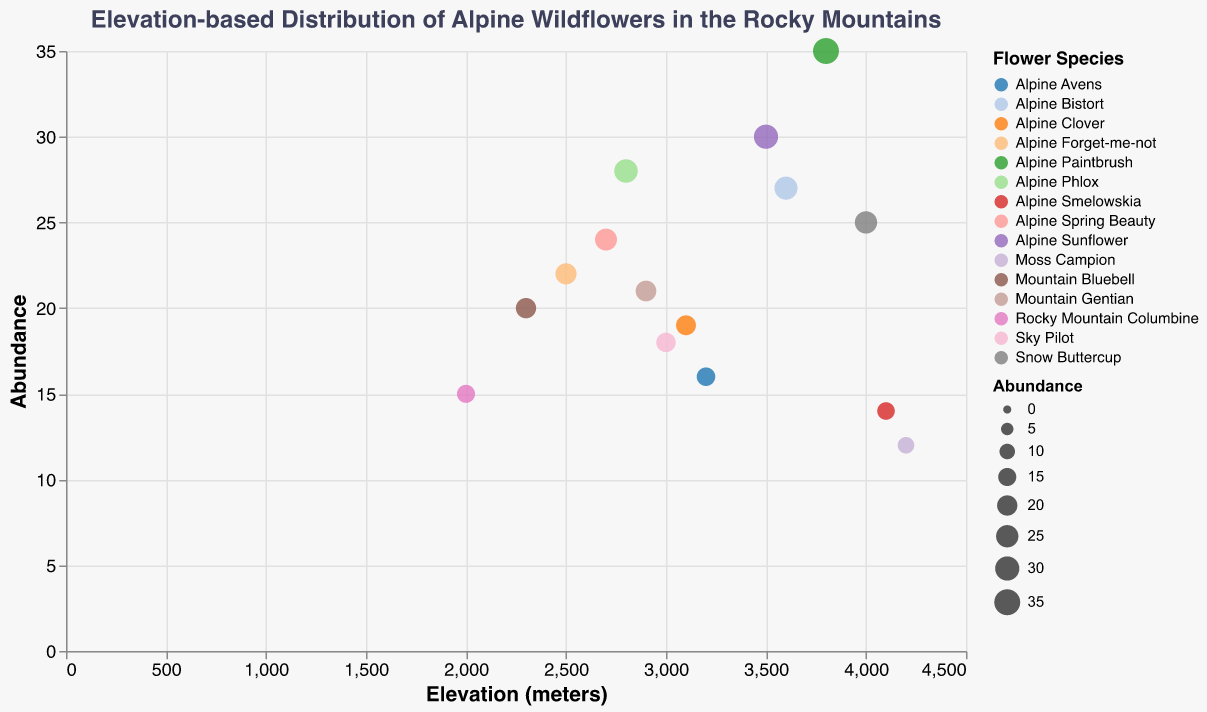What is the flower species with the highest abundance? Look at the y-axis representing abundance and identify the point with the highest value; the flower species corresponding to it is "Alpine Paintbrush".
Answer: Alpine Paintbrush Which flower species occurs at the highest elevation? Examine the x-axis representing elevation and find the point at the highest elevation. The flower species corresponding to it is "Moss Campion".
Answer: Moss Campion What is the average abundance of flowers found at or above 3000 meters? Identify the abundances of flowers at 3000 meters or above: Sky Pilot (18), Alpine Sunflower (30), Snow Buttercup (25), Alpine Avens (16), Alpine Paintbrush (35), Moss Campion (12), Alpine Clover (19), Alpine Bistort (27), Alpine Smelowskia (14). Sum these values: 18 + 30 + 25 + 16 + 35 + 12 + 19 + 27 + 14 = 196. There are 9 flowers, so average = 196 / 9.
Answer: 21.78 What is the difference in abundance between Rocky Mountain Columbine and Alpine Sunflower? Compare the y-axis values for both species: Rocky Mountain Columbine (15) and Alpine Sunflower (30). Calculate the difference: 30 - 15.
Answer: 15 Which flower species has the lowest abundance at an elevation between 3000 and 4000 meters? Focus on points between 3000 and 4000 meters on the x-axis. Compare their abundances: Sky Pilot (18), Alpine Avens (16), Alpine Clover (19), Alpine Bistort (27), Alpine Paintbrush (35), and Alpine Sunflower (30). The lowest value is for "Alpine Avens".
Answer: Alpine Avens Are there more flower species found above or below 3000 meters? Count the flower species above 3000 meters: Sky Pilot, Alpine Sunflower, Snow Buttercup, Alpine Avens, Alpine Paintbrush, Alpine Clover, Alpine Bistort, Alpine Smelowskia, Moss Campion (9 species). Count those below 3000 meters: Rocky Mountain Columbine, Alpine Forget-me-not, Mountain Bluebell, Alpine Phlox, Alpine Spring Beauty, Mountain Gentian (6 species). 9 is greater than 6, so more species are found above.
Answer: Above What elevation range has the highest modal abundance? Identify abundances and their frequencies within defined elevation ranges. The highest frequency of the modal abundance appears between 2700 meters (Alpine Spring Beauty) and 4100 meters (Alpine Smelowskia). The most frequently occurring value within this range is 24.
Answer: 2700-4100 meters 